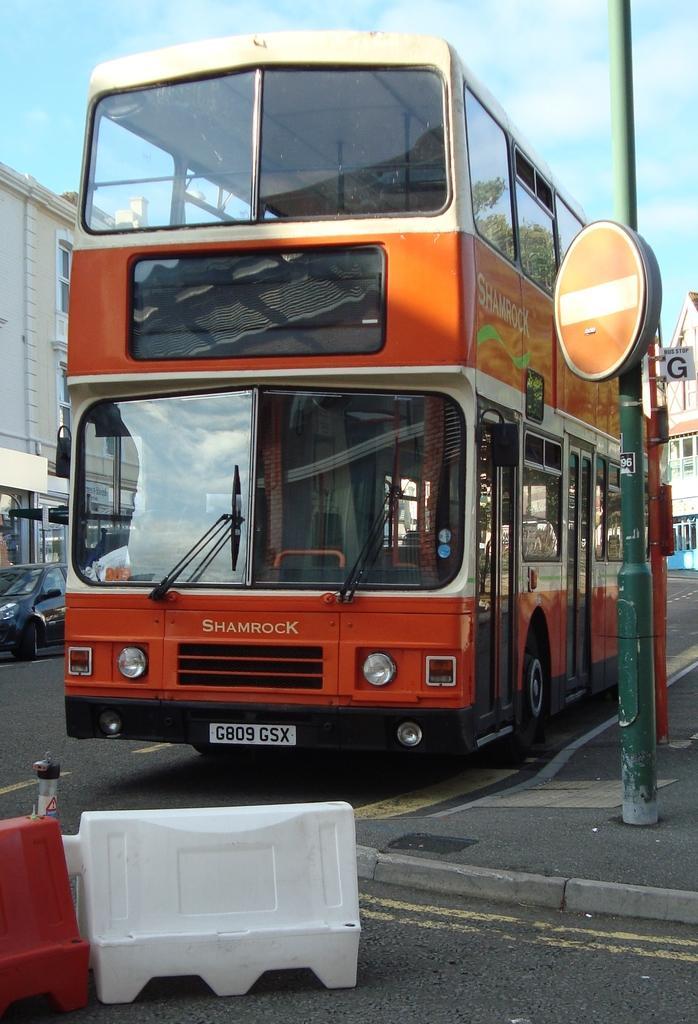Could you give a brief overview of what you see in this image? This picture consists double Decker bus in front of the bus I can see Boxes kept on road on the right side I can see building, pole at the top I can see the sky and tree , on the left side I can see building and car 